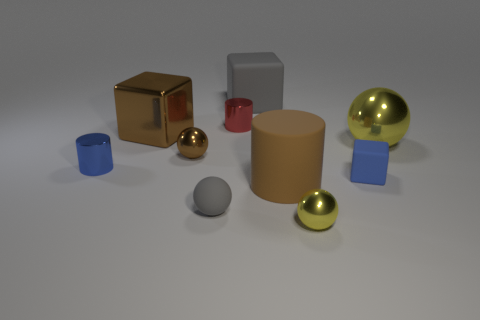Are there any metal objects to the right of the large brown cube?
Make the answer very short. Yes. Are there any other things that are the same shape as the red metal object?
Offer a very short reply. Yes. Does the brown matte object have the same shape as the big gray object?
Your response must be concise. No. Is the number of matte cylinders that are behind the matte cylinder the same as the number of metallic balls that are behind the tiny brown metallic sphere?
Keep it short and to the point. No. What number of other objects are there of the same material as the large brown cube?
Offer a very short reply. 5. What number of tiny objects are either metal objects or gray matte things?
Keep it short and to the point. 5. Are there the same number of brown metal objects that are in front of the rubber cylinder and tiny green cylinders?
Give a very brief answer. Yes. There is a small matte thing that is on the right side of the rubber cylinder; are there any tiny yellow things that are to the right of it?
Provide a short and direct response. No. What number of other things are there of the same color as the large metal ball?
Your answer should be compact. 1. What is the color of the big shiny block?
Your answer should be very brief. Brown. 